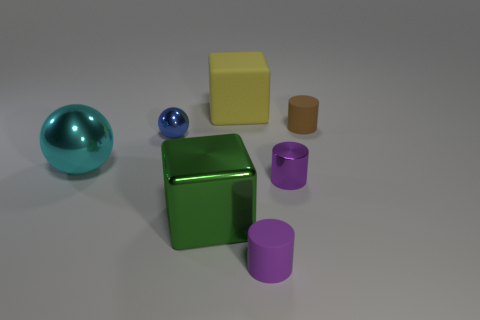Does the blue object have the same shape as the tiny purple metal thing?
Offer a very short reply. No. What color is the metal cube?
Offer a terse response. Green. How many other things are there of the same material as the yellow thing?
Provide a short and direct response. 2. What number of purple objects are tiny metallic cylinders or large objects?
Provide a short and direct response. 1. There is a large thing behind the cyan metal ball; is it the same shape as the small matte object behind the large metal ball?
Your answer should be compact. No. Do the shiny block and the small matte cylinder left of the brown rubber object have the same color?
Provide a short and direct response. No. Do the shiny object that is right of the purple rubber cylinder and the large shiny cube have the same color?
Give a very brief answer. No. What number of things are either shiny blocks or big blocks that are behind the small metallic cylinder?
Provide a succinct answer. 2. What is the material of the object that is behind the large cyan object and right of the yellow object?
Your response must be concise. Rubber. There is a block in front of the brown matte cylinder; what material is it?
Your response must be concise. Metal. 